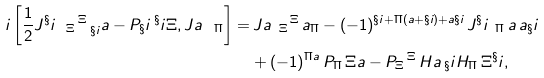<formula> <loc_0><loc_0><loc_500><loc_500>i \left [ \frac { 1 } { 2 } J ^ { \S } i _ { \ \, \Xi } \, ^ { \Xi } _ { \ \, \S i } \L a - P _ { \S } i \, ^ { \S } i \Xi , J ^ { \L } a _ { \ \, \Pi } \right ] = & \, J ^ { \L } a _ { \ \, \Xi } \, ^ { \Xi } \, \L a _ { \Pi } - ( - 1 ) ^ { \S i + \Pi ( \L a + \S i ) + \L a \S i } \, J ^ { \S } i _ { \ \, \Pi } \, ^ { \L } a \, \L a _ { \S } i \\ & + ( - 1 ) ^ { \Pi \L a } \, P _ { \Pi } \, \Xi ^ { \L } a - P _ { \Xi } \, ^ { \Xi } \, H ^ { \L } a \, _ { \S } i H _ { \Pi } \, \Xi ^ { \S } i ,</formula> 